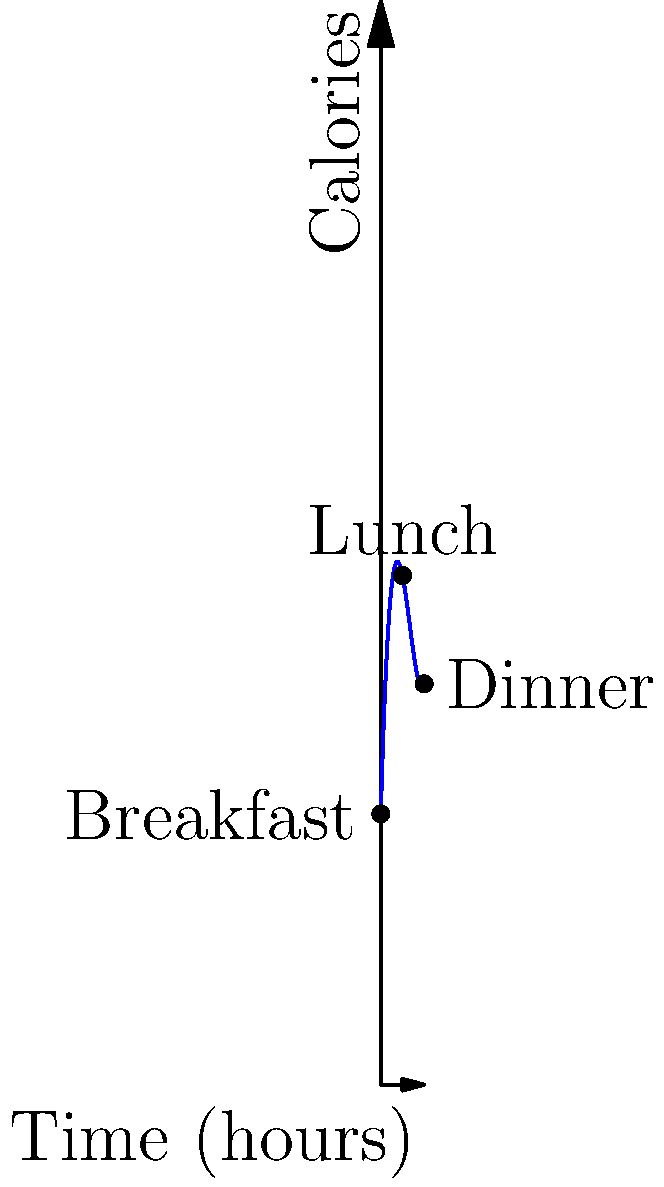The graph above represents the calorie content of snacks consumed during screen time breaks over a day. The function is given by $f(x) = 0.5x^3 - 8x^2 + 35x + 50$, where $x$ is the time in hours since breakfast (at $x=0$) and $f(x)$ is the calorie content. Calculate the total calorie intake from snacks between lunch (at $x=4$) and dinner (at $x=8$). To find the total calorie intake from snacks between lunch and dinner, we need to:

1) Calculate the area under the curve from $x=4$ to $x=8$.
2) This is done by integrating the function $f(x)$ from 4 to 8.

Step 1: Set up the definite integral
$$\int_{4}^{8} (0.5x^3 - 8x^2 + 35x + 50) dx$$

Step 2: Integrate the function
$$\left[\frac{0.5x^4}{4} - \frac{8x^3}{3} + \frac{35x^2}{2} + 50x\right]_{4}^{8}$$

Step 3: Evaluate the integral at the upper and lower bounds
Upper bound (x = 8):
$$\frac{0.5(8^4)}{4} - \frac{8(8^3)}{3} + \frac{35(8^2)}{2} + 50(8) = 512 - 1365.33 + 1120 + 400 = 666.67$$

Lower bound (x = 4):
$$\frac{0.5(4^4)}{4} - \frac{8(4^3)}{3} + \frac{35(4^2)}{2} + 50(4) = 32 - 170.67 + 280 + 200 = 341.33$$

Step 4: Subtract the lower bound from the upper bound
$$666.67 - 341.33 = 325.34$$

Therefore, the total calorie intake from snacks between lunch and dinner is approximately 325 calories.
Answer: 325 calories 